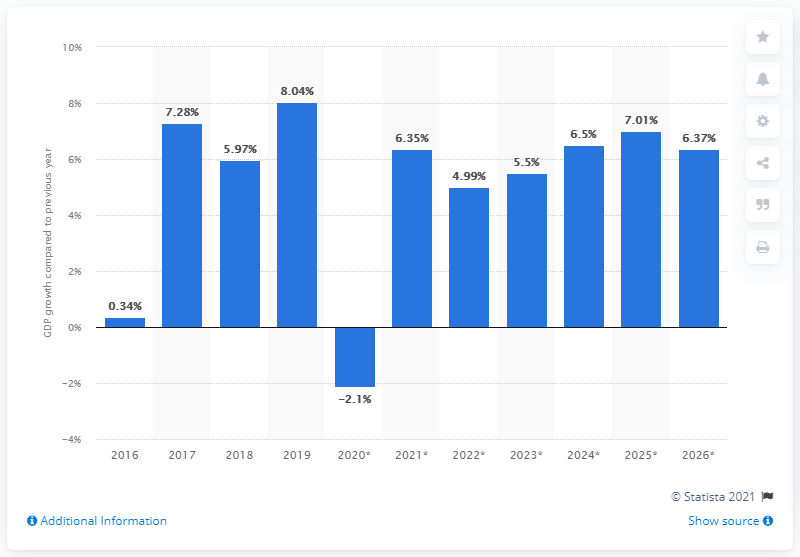Draw attention to some important aspects in this diagram. The Gross Domestic Product of Uganda increased by 8.04% in 2019. 